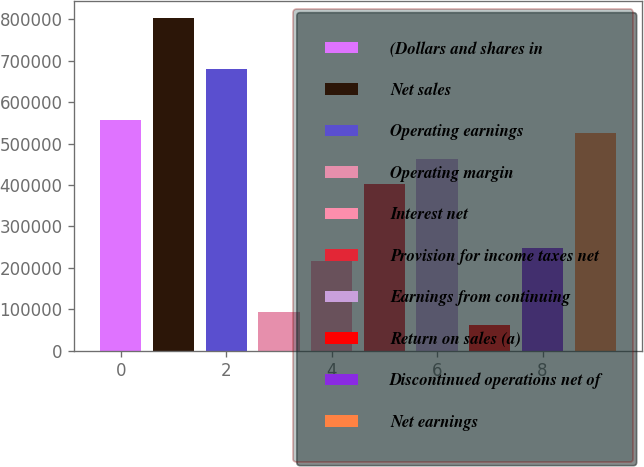<chart> <loc_0><loc_0><loc_500><loc_500><bar_chart><fcel>(Dollars and shares in<fcel>Net sales<fcel>Operating earnings<fcel>Operating margin<fcel>Interest net<fcel>Provision for income taxes net<fcel>Earnings from continuing<fcel>Return on sales (a)<fcel>Discontinued operations net of<fcel>Net earnings<nl><fcel>556739<fcel>804179<fcel>680459<fcel>92790.6<fcel>216510<fcel>402090<fcel>463950<fcel>61860.7<fcel>247440<fcel>525809<nl></chart> 